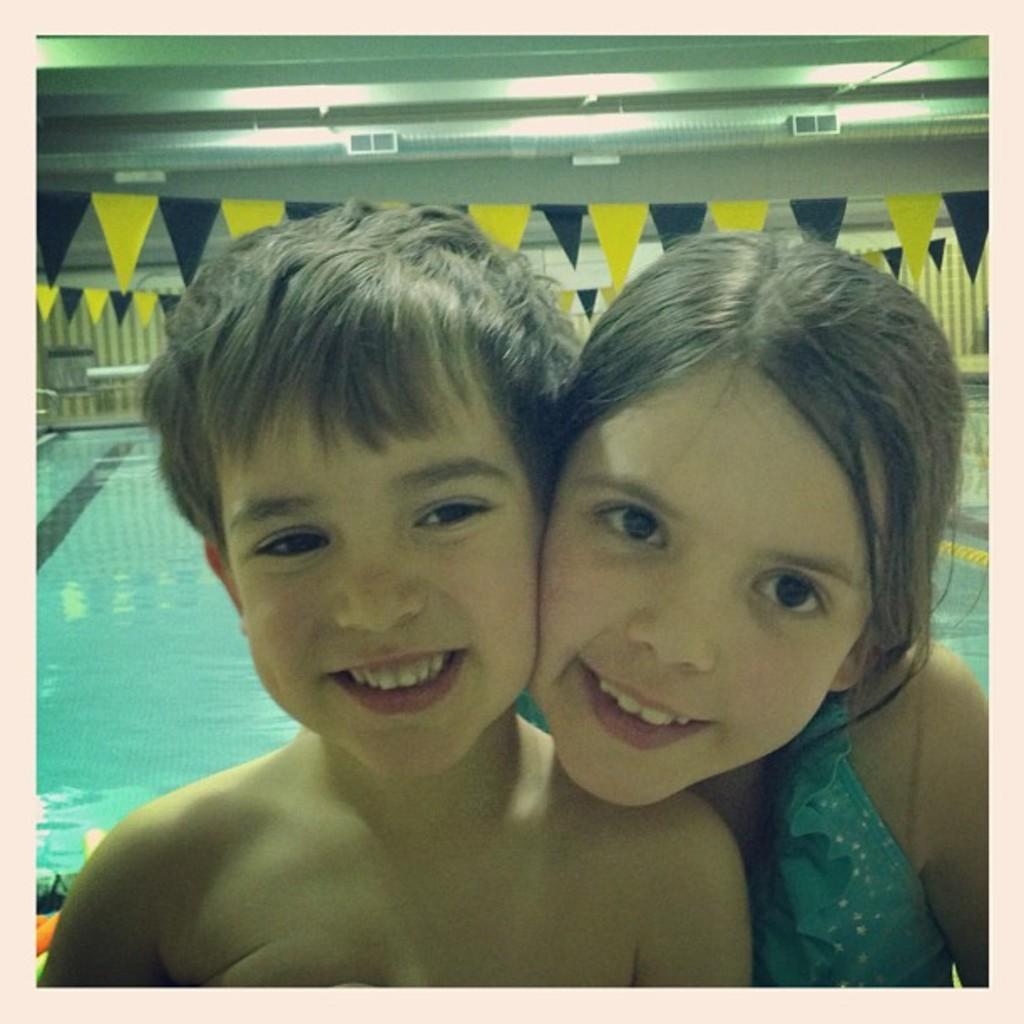Describe this image in one or two sentences. In this image we can see a girl and a boy smiling. In the background there is a pool and we can see flags. In the background there is a wall. 